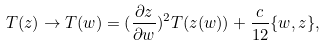Convert formula to latex. <formula><loc_0><loc_0><loc_500><loc_500>T ( z ) \rightarrow T ( w ) = ( \frac { \partial z } { \partial w } ) ^ { 2 } T ( z ( w ) ) + \frac { c } { 1 2 } \{ w , z \} ,</formula> 